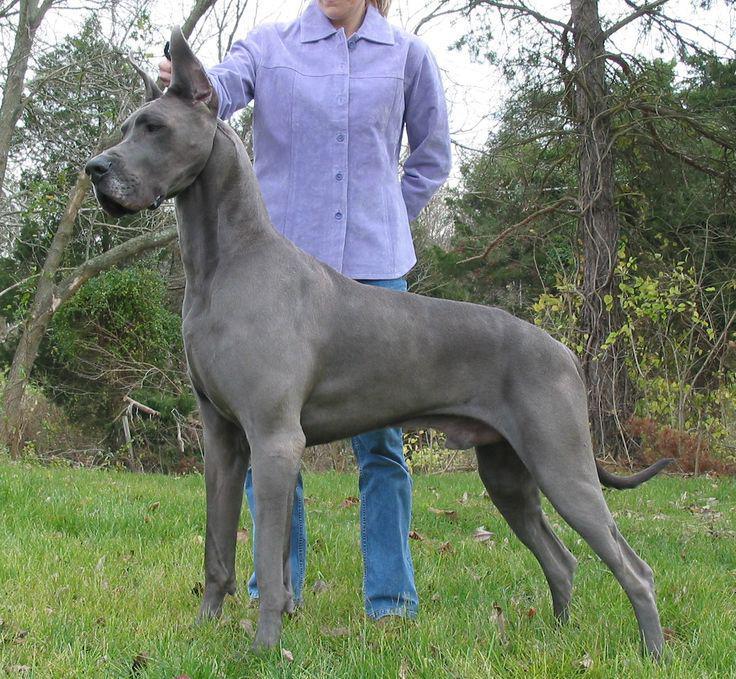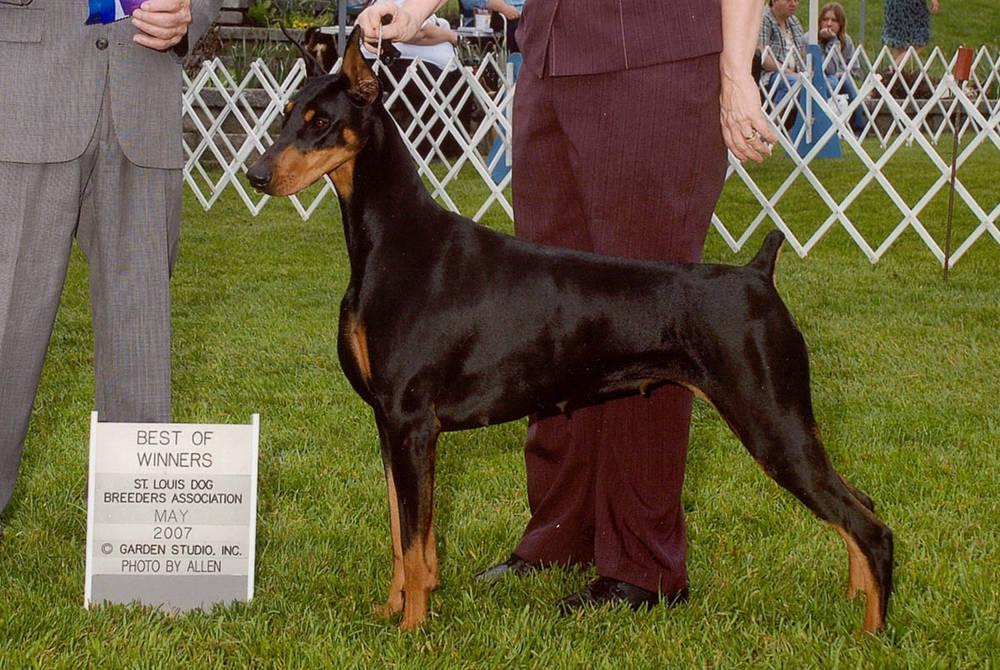The first image is the image on the left, the second image is the image on the right. Analyze the images presented: Is the assertion "There is only one dog with a collar" valid? Answer yes or no. No. The first image is the image on the left, the second image is the image on the right. Analyze the images presented: Is the assertion "The right image features a pointy-eared black-and-tan doberman with docked tail standing with its body turned leftward." valid? Answer yes or no. Yes. 